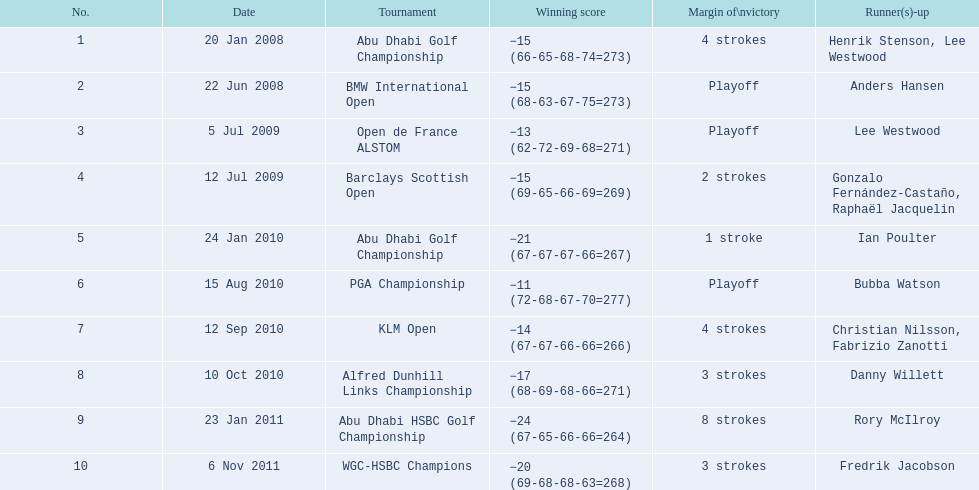What was martin kaymer's stroke count in the klm open? 4 strokes. What was the stroke count for the abu dhabi golf championship? 4 strokes. How many more strokes were present in the klm than in the barclays open? 2 strokes. 